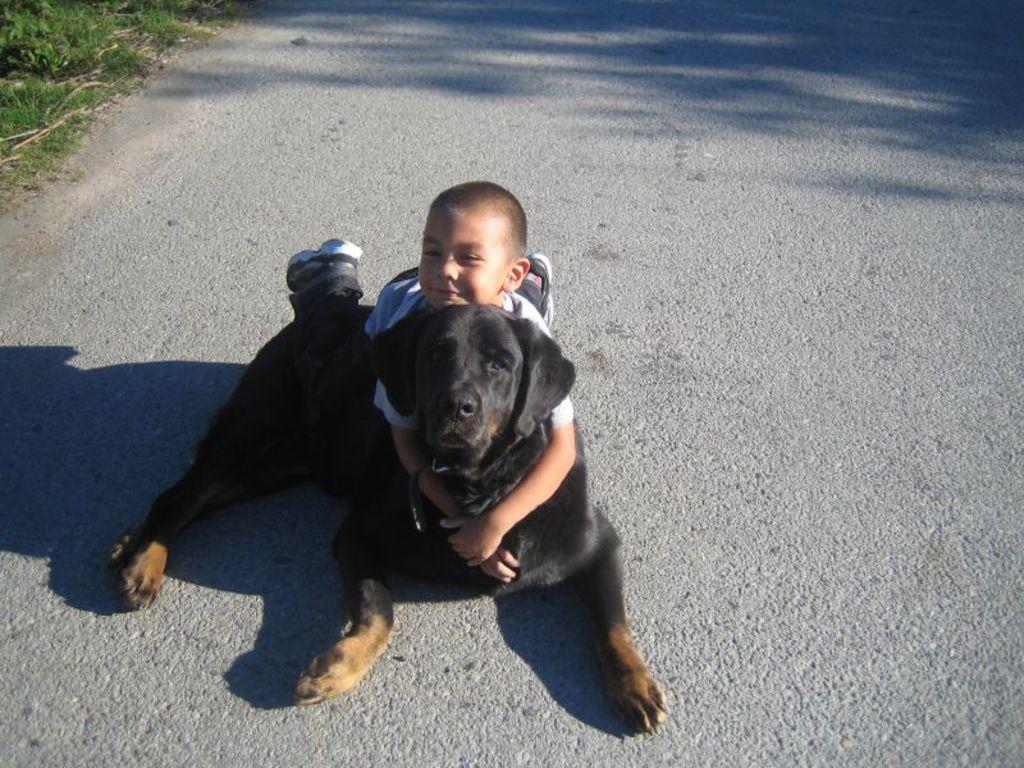Please provide a concise description of this image. In this picture a small kid is holding on a black dog and both are resting on the floor. To the top left corner of the image we find small trees. 